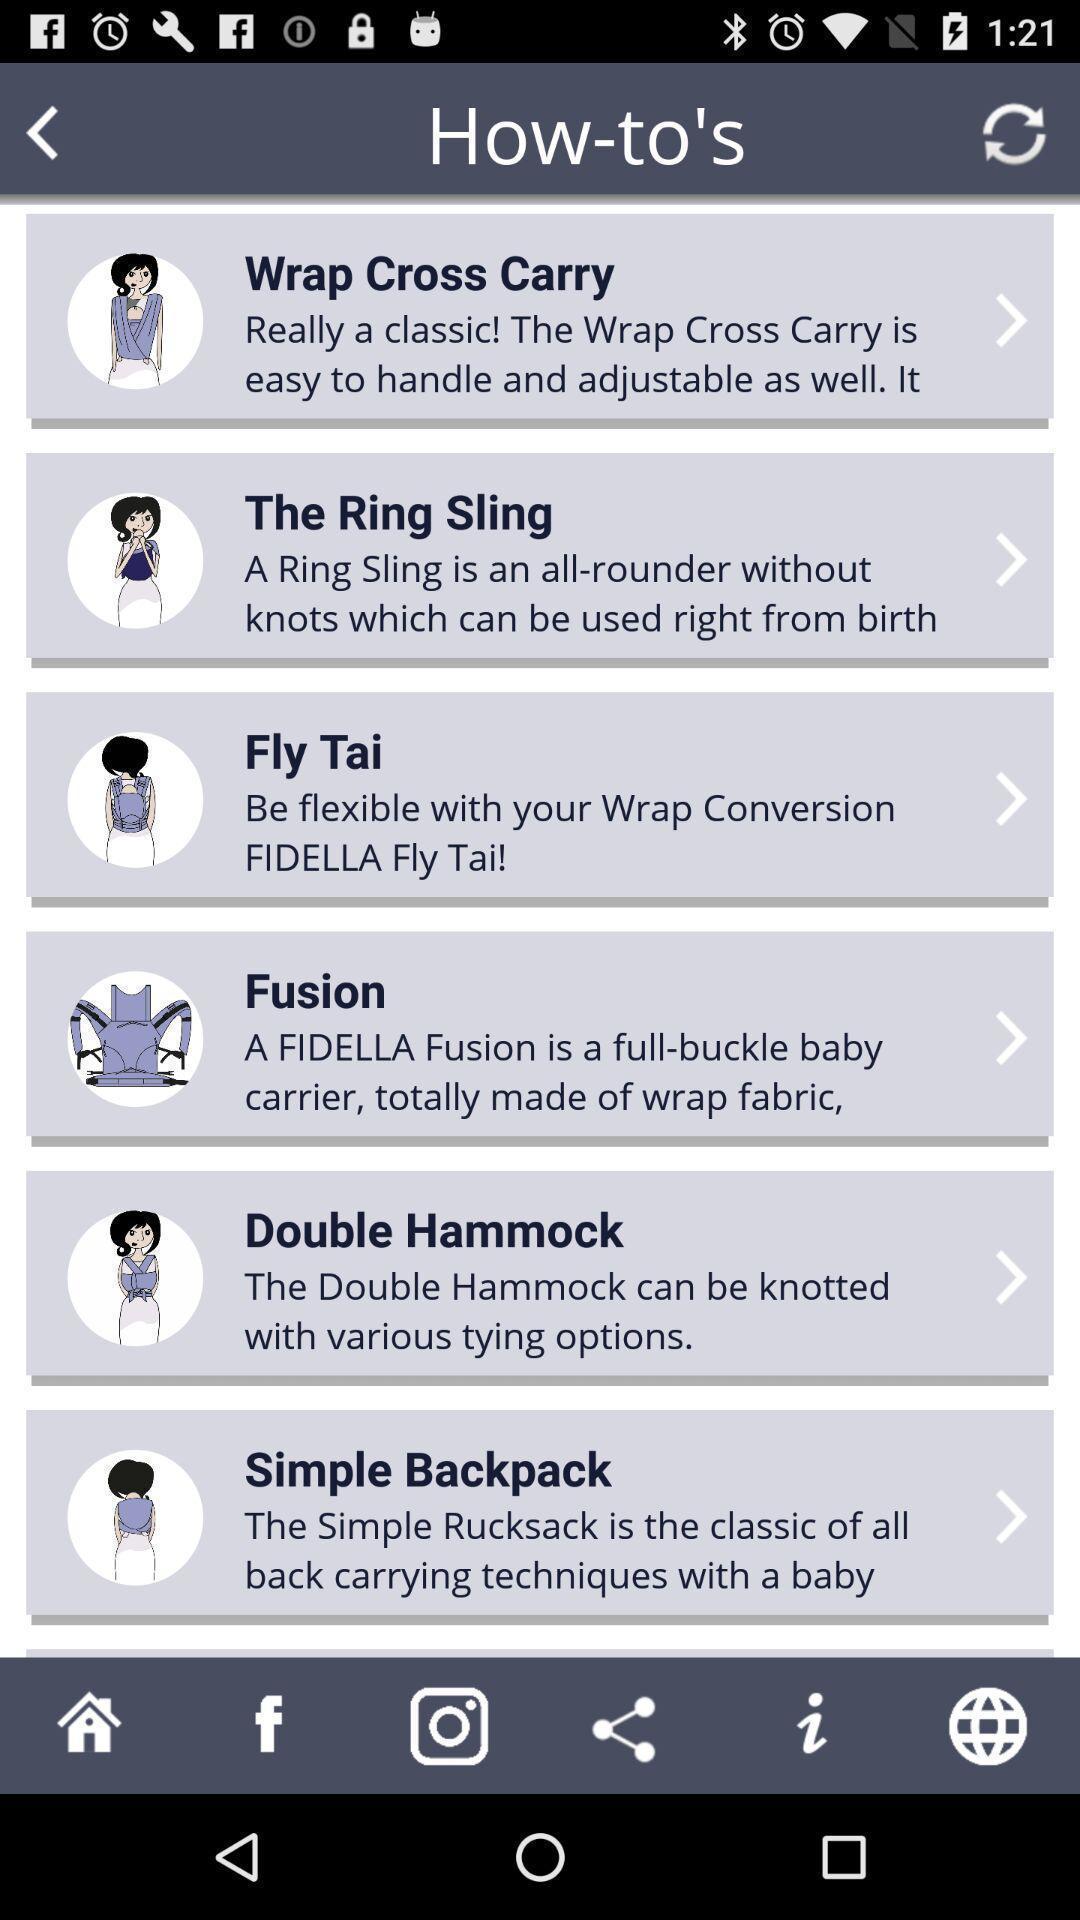Summarize the information in this screenshot. Screen page displaying about how to carry a baby. 